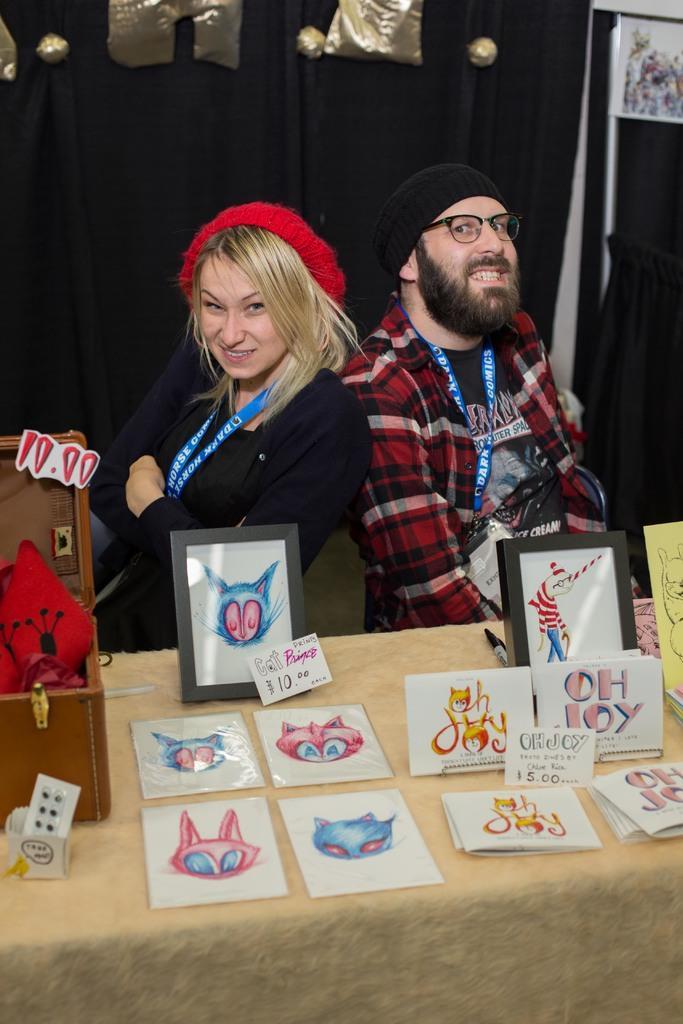In one or two sentences, can you explain what this image depicts? In this image, there are a few people. We can also see a table covered with a cloth with some objects like posters. We can also see a wooden box with some objects. In the background, we can see some curtains with objects. 